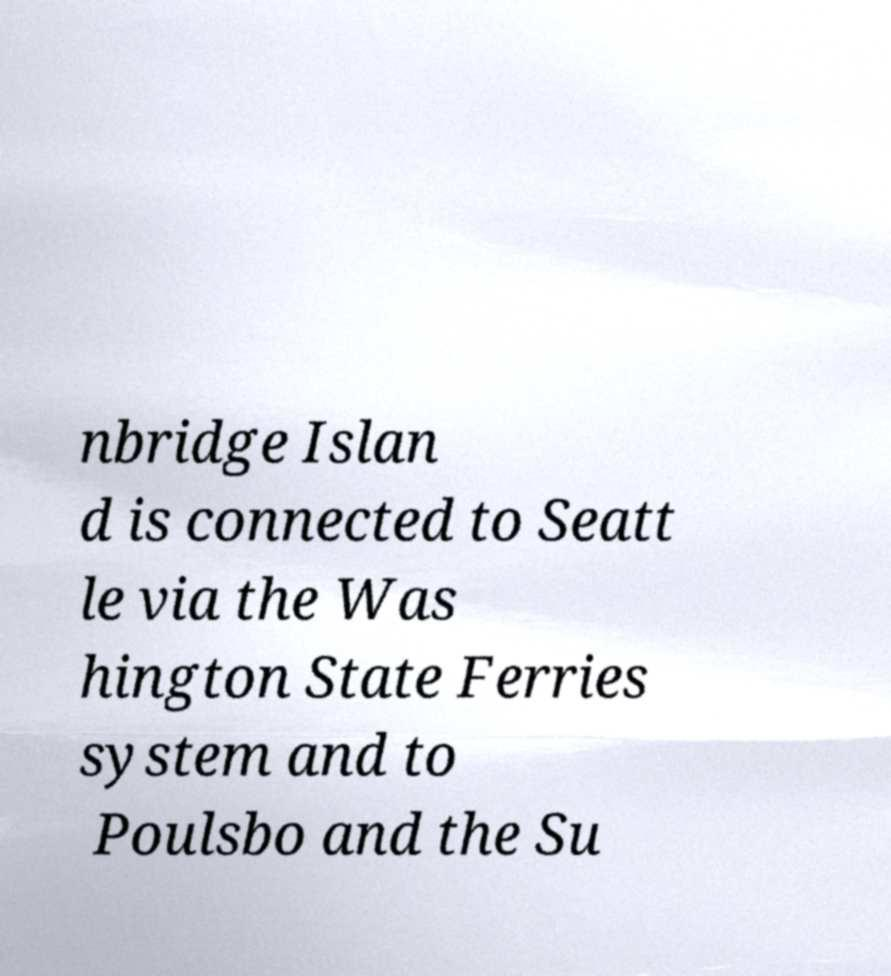I need the written content from this picture converted into text. Can you do that? nbridge Islan d is connected to Seatt le via the Was hington State Ferries system and to Poulsbo and the Su 